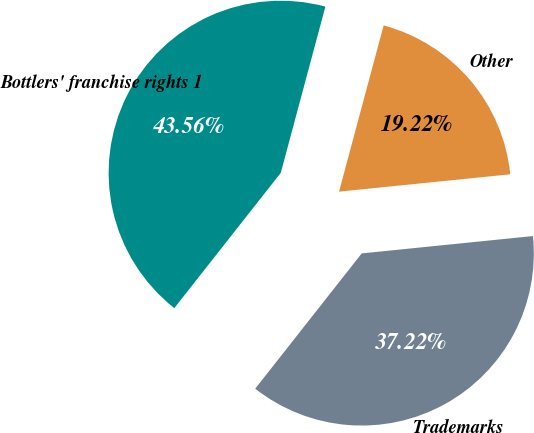<chart> <loc_0><loc_0><loc_500><loc_500><pie_chart><fcel>Bottlers' franchise rights 1<fcel>Trademarks<fcel>Other<nl><fcel>43.56%<fcel>37.22%<fcel>19.22%<nl></chart> 